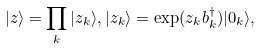<formula> <loc_0><loc_0><loc_500><loc_500>| z \rangle = \prod _ { k } | z _ { k } \rangle , | z _ { k } \rangle = \exp ( z _ { k } b _ { k } ^ { \dagger } ) | 0 _ { k } \rangle ,</formula> 